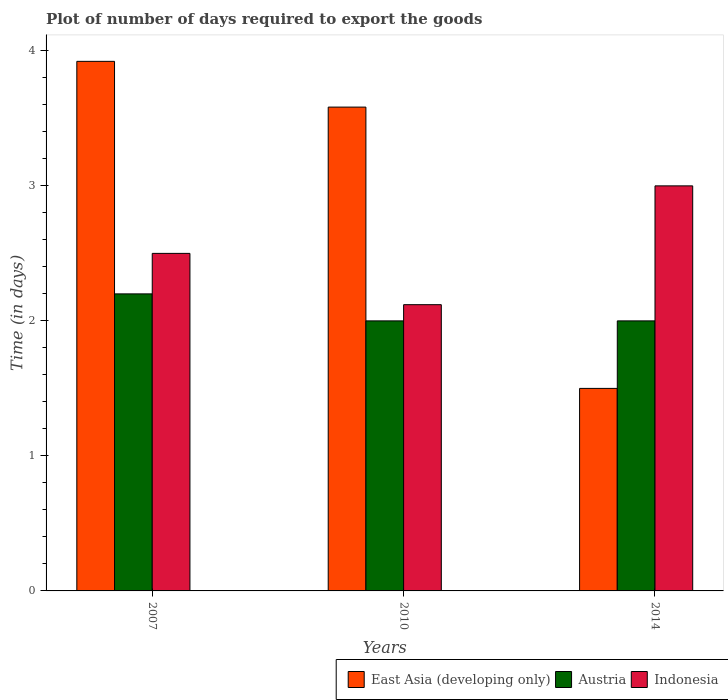How many different coloured bars are there?
Your answer should be very brief. 3. How many groups of bars are there?
Make the answer very short. 3. Are the number of bars on each tick of the X-axis equal?
Your answer should be very brief. Yes. How many bars are there on the 1st tick from the left?
Provide a short and direct response. 3. How many bars are there on the 3rd tick from the right?
Offer a terse response. 3. What is the label of the 2nd group of bars from the left?
Keep it short and to the point. 2010. In how many cases, is the number of bars for a given year not equal to the number of legend labels?
Give a very brief answer. 0. What is the time required to export goods in Indonesia in 2007?
Keep it short and to the point. 2.5. Across all years, what is the maximum time required to export goods in Indonesia?
Offer a very short reply. 3. In which year was the time required to export goods in East Asia (developing only) maximum?
Offer a very short reply. 2007. In which year was the time required to export goods in Indonesia minimum?
Provide a short and direct response. 2010. What is the total time required to export goods in Austria in the graph?
Your answer should be very brief. 6.2. What is the difference between the time required to export goods in Austria in 2010 and that in 2014?
Your answer should be compact. 0. What is the difference between the time required to export goods in Austria in 2007 and the time required to export goods in Indonesia in 2010?
Provide a short and direct response. 0.08. What is the average time required to export goods in Indonesia per year?
Your answer should be compact. 2.54. In the year 2007, what is the difference between the time required to export goods in East Asia (developing only) and time required to export goods in Austria?
Your response must be concise. 1.72. What is the ratio of the time required to export goods in Austria in 2007 to that in 2010?
Provide a short and direct response. 1.1. What is the difference between the highest and the second highest time required to export goods in Austria?
Offer a very short reply. 0.2. What is the difference between the highest and the lowest time required to export goods in East Asia (developing only)?
Your response must be concise. 2.42. In how many years, is the time required to export goods in East Asia (developing only) greater than the average time required to export goods in East Asia (developing only) taken over all years?
Keep it short and to the point. 2. What does the 1st bar from the left in 2010 represents?
Offer a very short reply. East Asia (developing only). How many bars are there?
Your answer should be compact. 9. Are all the bars in the graph horizontal?
Provide a succinct answer. No. How many years are there in the graph?
Keep it short and to the point. 3. Where does the legend appear in the graph?
Make the answer very short. Bottom right. How many legend labels are there?
Provide a succinct answer. 3. What is the title of the graph?
Ensure brevity in your answer.  Plot of number of days required to export the goods. What is the label or title of the Y-axis?
Give a very brief answer. Time (in days). What is the Time (in days) in East Asia (developing only) in 2007?
Offer a very short reply. 3.92. What is the Time (in days) of East Asia (developing only) in 2010?
Your response must be concise. 3.58. What is the Time (in days) of Austria in 2010?
Your response must be concise. 2. What is the Time (in days) in Indonesia in 2010?
Your response must be concise. 2.12. Across all years, what is the maximum Time (in days) of East Asia (developing only)?
Keep it short and to the point. 3.92. Across all years, what is the maximum Time (in days) in Indonesia?
Offer a terse response. 3. Across all years, what is the minimum Time (in days) of East Asia (developing only)?
Give a very brief answer. 1.5. Across all years, what is the minimum Time (in days) in Indonesia?
Ensure brevity in your answer.  2.12. What is the total Time (in days) of East Asia (developing only) in the graph?
Provide a succinct answer. 9.01. What is the total Time (in days) in Indonesia in the graph?
Offer a very short reply. 7.62. What is the difference between the Time (in days) in East Asia (developing only) in 2007 and that in 2010?
Give a very brief answer. 0.34. What is the difference between the Time (in days) in Indonesia in 2007 and that in 2010?
Your answer should be very brief. 0.38. What is the difference between the Time (in days) of East Asia (developing only) in 2007 and that in 2014?
Provide a short and direct response. 2.42. What is the difference between the Time (in days) of Indonesia in 2007 and that in 2014?
Your answer should be very brief. -0.5. What is the difference between the Time (in days) of East Asia (developing only) in 2010 and that in 2014?
Provide a short and direct response. 2.08. What is the difference between the Time (in days) in Austria in 2010 and that in 2014?
Your response must be concise. 0. What is the difference between the Time (in days) in Indonesia in 2010 and that in 2014?
Your response must be concise. -0.88. What is the difference between the Time (in days) of East Asia (developing only) in 2007 and the Time (in days) of Austria in 2010?
Ensure brevity in your answer.  1.92. What is the difference between the Time (in days) in East Asia (developing only) in 2007 and the Time (in days) in Indonesia in 2010?
Your answer should be compact. 1.8. What is the difference between the Time (in days) of Austria in 2007 and the Time (in days) of Indonesia in 2010?
Ensure brevity in your answer.  0.08. What is the difference between the Time (in days) in East Asia (developing only) in 2007 and the Time (in days) in Austria in 2014?
Offer a terse response. 1.92. What is the difference between the Time (in days) of East Asia (developing only) in 2007 and the Time (in days) of Indonesia in 2014?
Ensure brevity in your answer.  0.92. What is the difference between the Time (in days) in East Asia (developing only) in 2010 and the Time (in days) in Austria in 2014?
Your response must be concise. 1.58. What is the difference between the Time (in days) in East Asia (developing only) in 2010 and the Time (in days) in Indonesia in 2014?
Offer a very short reply. 0.58. What is the average Time (in days) of East Asia (developing only) per year?
Give a very brief answer. 3. What is the average Time (in days) of Austria per year?
Your answer should be compact. 2.07. What is the average Time (in days) of Indonesia per year?
Offer a very short reply. 2.54. In the year 2007, what is the difference between the Time (in days) in East Asia (developing only) and Time (in days) in Austria?
Your response must be concise. 1.72. In the year 2007, what is the difference between the Time (in days) in East Asia (developing only) and Time (in days) in Indonesia?
Your answer should be compact. 1.42. In the year 2010, what is the difference between the Time (in days) of East Asia (developing only) and Time (in days) of Austria?
Provide a short and direct response. 1.58. In the year 2010, what is the difference between the Time (in days) of East Asia (developing only) and Time (in days) of Indonesia?
Keep it short and to the point. 1.46. In the year 2010, what is the difference between the Time (in days) in Austria and Time (in days) in Indonesia?
Ensure brevity in your answer.  -0.12. In the year 2014, what is the difference between the Time (in days) in East Asia (developing only) and Time (in days) in Austria?
Make the answer very short. -0.5. In the year 2014, what is the difference between the Time (in days) in East Asia (developing only) and Time (in days) in Indonesia?
Give a very brief answer. -1.5. In the year 2014, what is the difference between the Time (in days) of Austria and Time (in days) of Indonesia?
Make the answer very short. -1. What is the ratio of the Time (in days) in East Asia (developing only) in 2007 to that in 2010?
Make the answer very short. 1.09. What is the ratio of the Time (in days) in Indonesia in 2007 to that in 2010?
Ensure brevity in your answer.  1.18. What is the ratio of the Time (in days) of East Asia (developing only) in 2007 to that in 2014?
Ensure brevity in your answer.  2.61. What is the ratio of the Time (in days) in Indonesia in 2007 to that in 2014?
Your response must be concise. 0.83. What is the ratio of the Time (in days) in East Asia (developing only) in 2010 to that in 2014?
Offer a terse response. 2.39. What is the ratio of the Time (in days) of Austria in 2010 to that in 2014?
Ensure brevity in your answer.  1. What is the ratio of the Time (in days) in Indonesia in 2010 to that in 2014?
Offer a terse response. 0.71. What is the difference between the highest and the second highest Time (in days) in East Asia (developing only)?
Offer a terse response. 0.34. What is the difference between the highest and the second highest Time (in days) of Austria?
Ensure brevity in your answer.  0.2. What is the difference between the highest and the lowest Time (in days) of East Asia (developing only)?
Your response must be concise. 2.42. What is the difference between the highest and the lowest Time (in days) of Indonesia?
Ensure brevity in your answer.  0.88. 